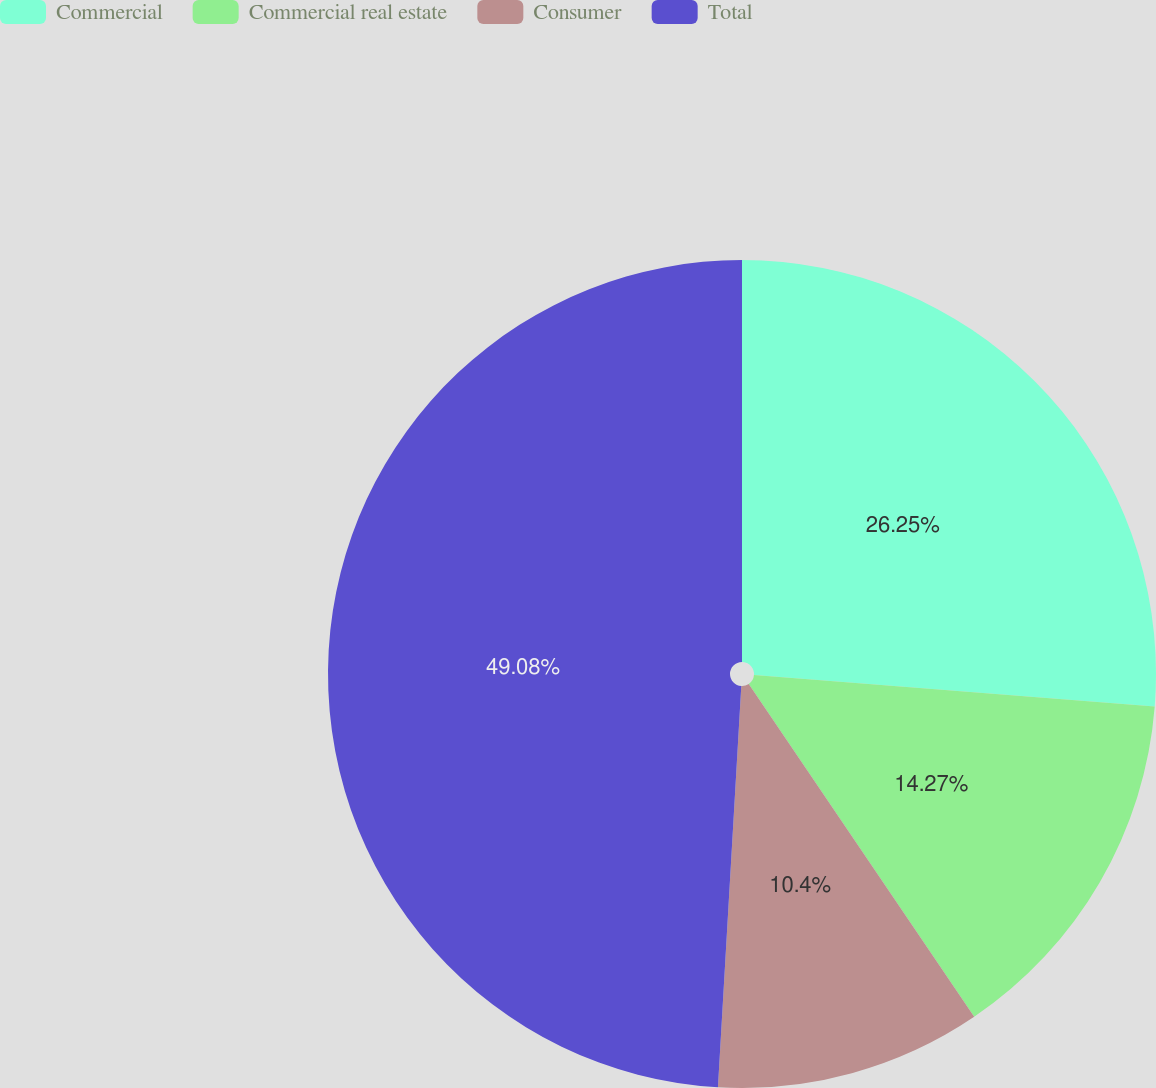Convert chart to OTSL. <chart><loc_0><loc_0><loc_500><loc_500><pie_chart><fcel>Commercial<fcel>Commercial real estate<fcel>Consumer<fcel>Total<nl><fcel>26.25%<fcel>14.27%<fcel>10.4%<fcel>49.07%<nl></chart> 